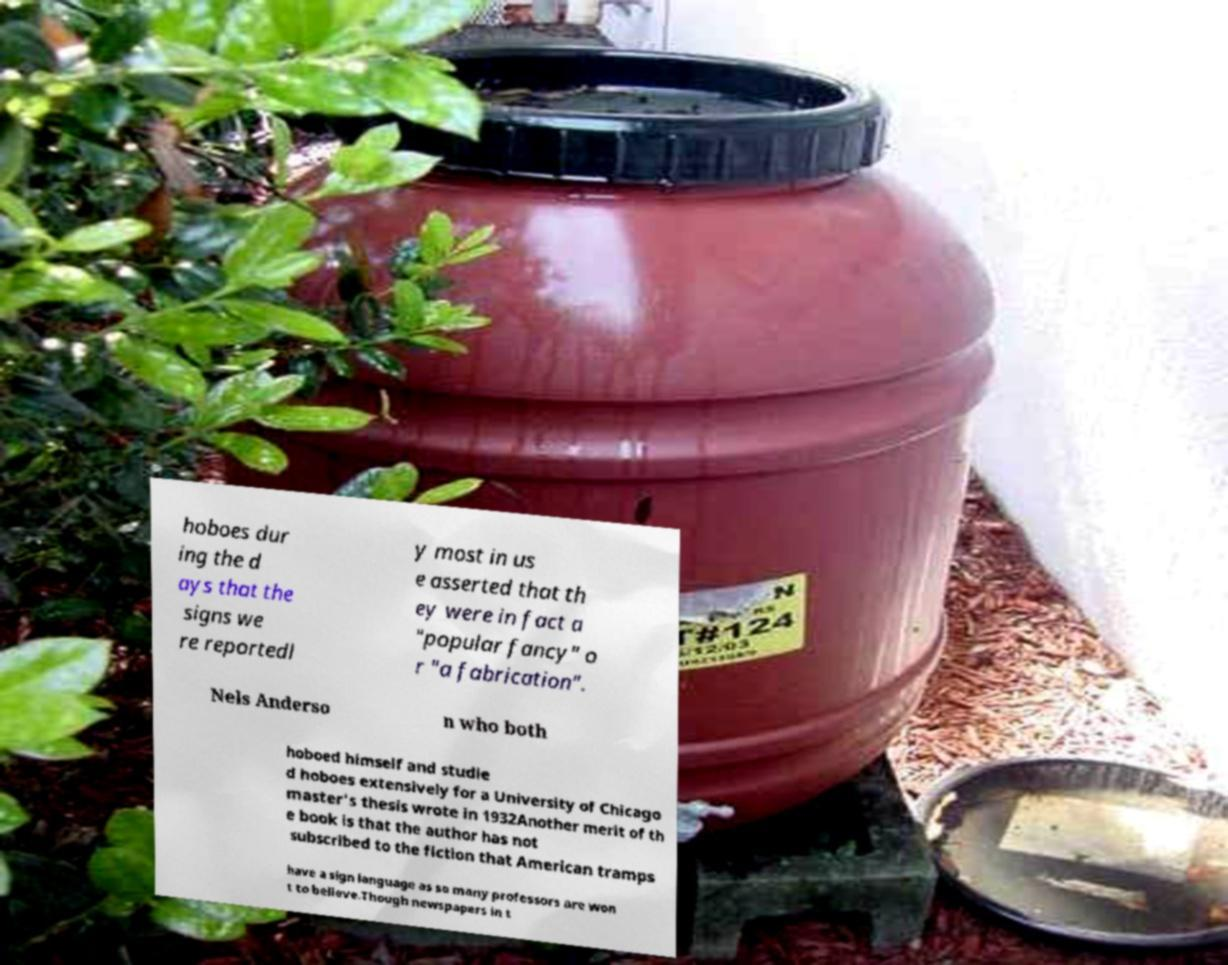Can you read and provide the text displayed in the image?This photo seems to have some interesting text. Can you extract and type it out for me? hoboes dur ing the d ays that the signs we re reportedl y most in us e asserted that th ey were in fact a "popular fancy" o r "a fabrication". Nels Anderso n who both hoboed himself and studie d hoboes extensively for a University of Chicago master's thesis wrote in 1932Another merit of th e book is that the author has not subscribed to the fiction that American tramps have a sign language as so many professors are won t to believe.Though newspapers in t 